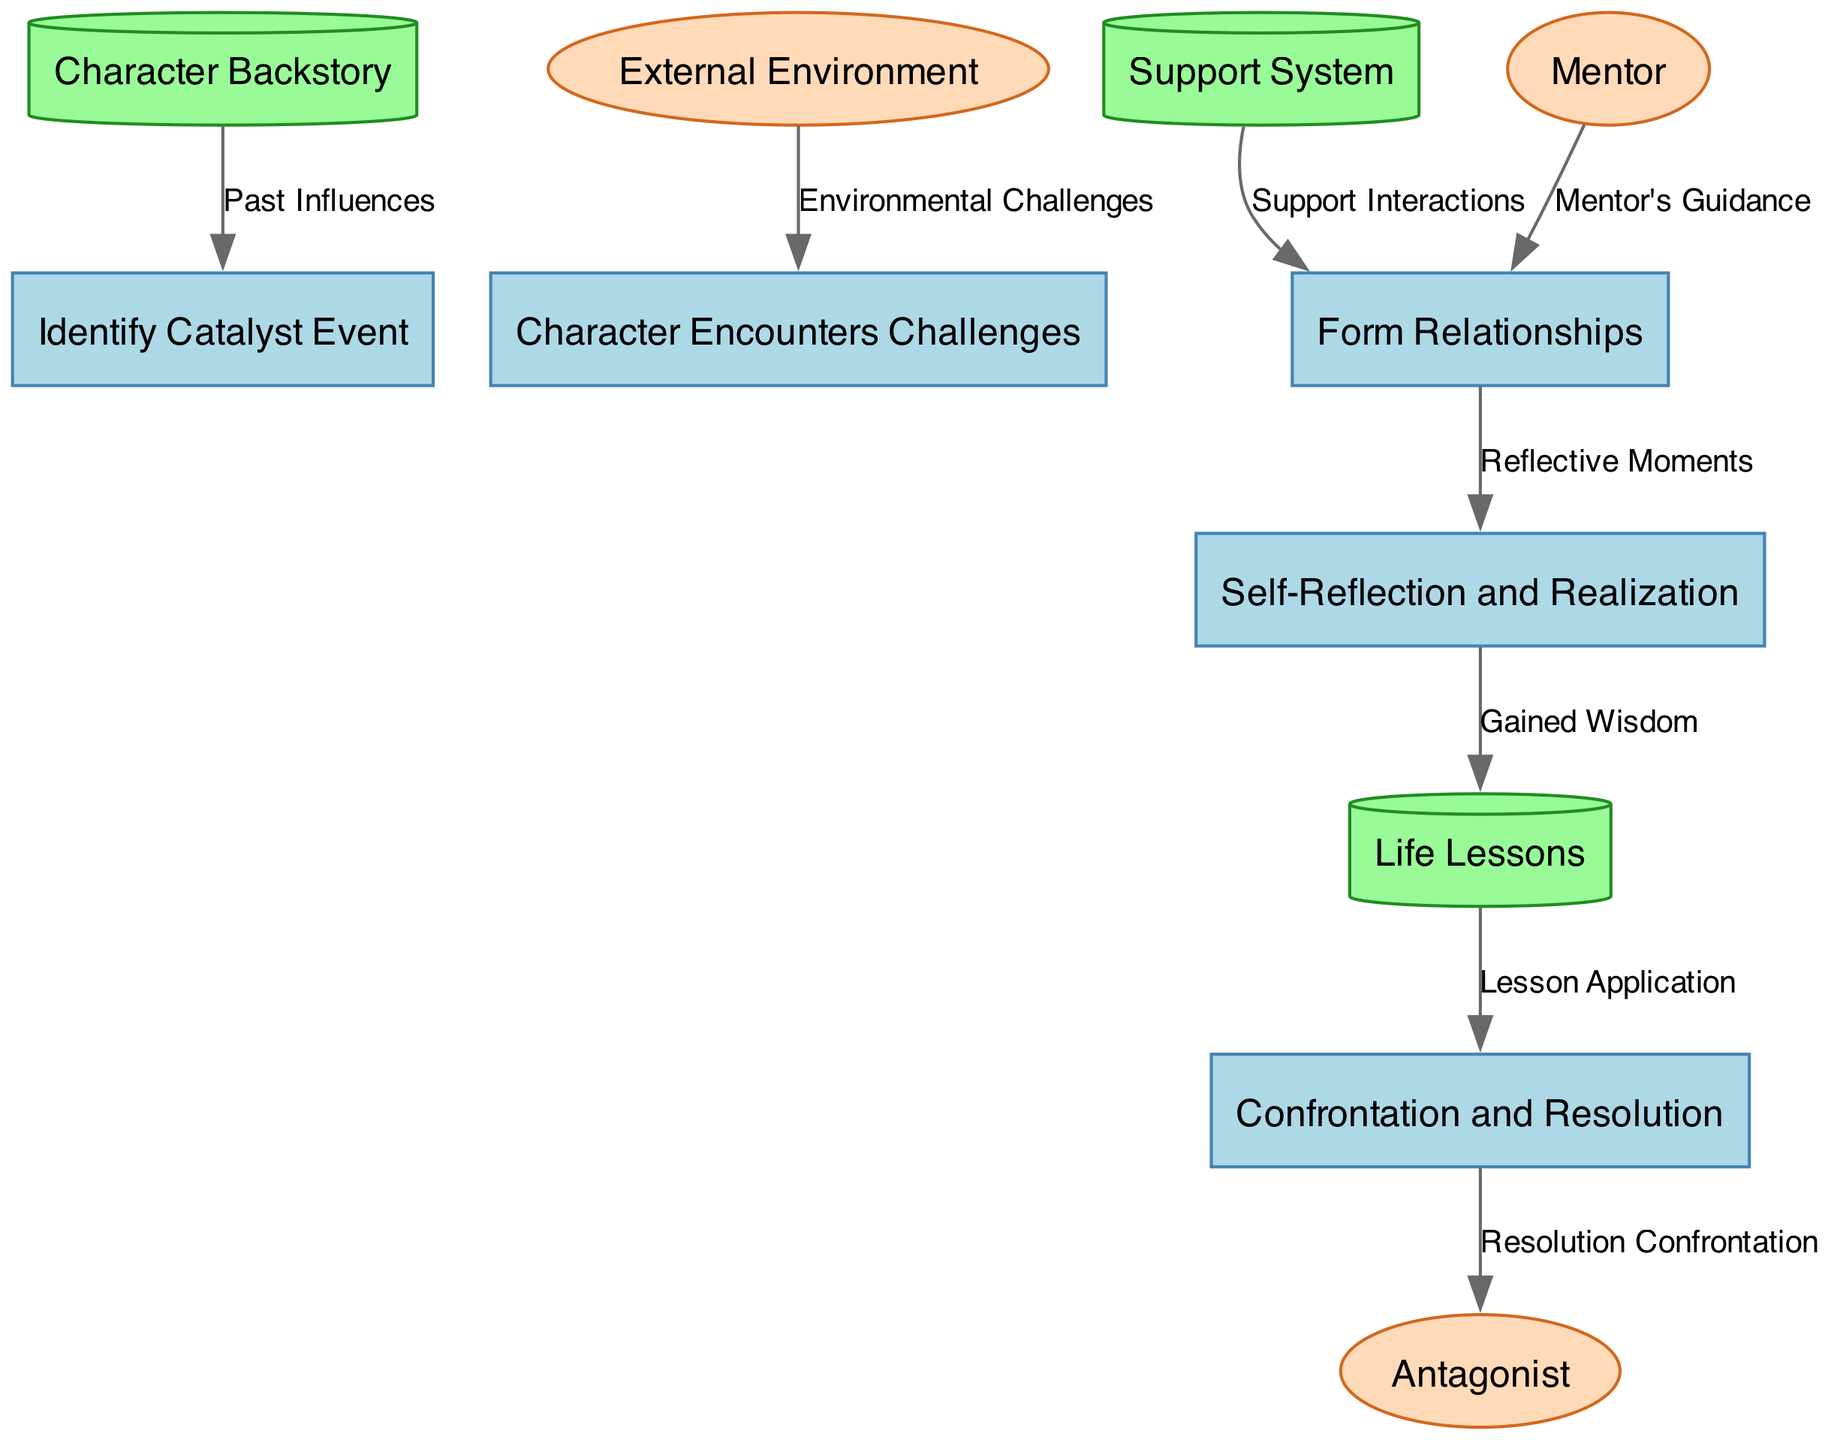What is the name of the first process in the diagram? The first process identified in the diagram is "Identify Catalyst Event." This is obtained by locating the process nodes and taking the first one listed.
Answer: Identify Catalyst Event How many data stores are depicted in the diagram? The diagram contains three data stores, as indicated by the number of distinct cylinder-shaped nodes representing data storage.
Answer: 3 What is the source of the data flow that leads to "Character Encounters Challenges"? The source of the data flow leading to "Character Encounters Challenges" is "External Environment." This is determined by tracing the edge connecting the external entity to the process.
Answer: External Environment What type of node is "Support System"? "Support System" is a data store node, which can be recognized by its shape (cylinder) and the context indicating it is providing background data related to character development.
Answer: Data Store Which process uses "Mentor's Guidance"? The process that uses "Mentor's Guidance" is "Form Relationships." This is identified by examining the flow connecting the external entity "Mentor" to the corresponding process node.
Answer: Form Relationships How many edges are present in the diagram? The diagram has eight edges, as counted by identifying all the directed lines connecting sources to their corresponding processes or storages.
Answer: 8 What insight is gained from the flow from "Self-Reflection and Realization" to "Life Lessons"? The flow from "Self-Reflection and Realization" to "Life Lessons" captures "Gained Wisdom." This indicates that insights from self-reflection contribute to the accumulation of life lessons.
Answer: Gained Wisdom What is the final process the character engages in before resolution? The final process before resolution is "Confrontation and Resolution." This can be seen as the last process node leading towards the end of the character's development journey.
Answer: Confrontation and Resolution Which external entity is involved in the concluding confrontation of the character's journey? The external entity involved in the concluding confrontation is the "Antagonist." This is identified by tracing the flow directed from the process "Confrontation and Resolution" to the antagonist's node.
Answer: Antagonist 